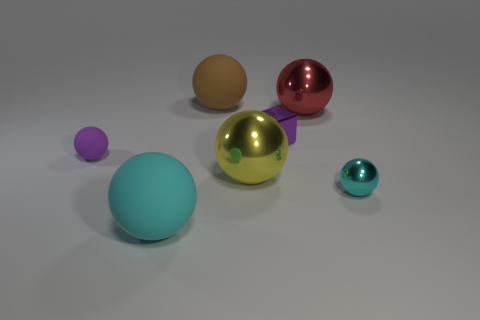Subtract 2 balls. How many balls are left? 4 Subtract all brown balls. How many balls are left? 5 Subtract all cyan balls. How many balls are left? 4 Subtract all purple balls. Subtract all yellow cylinders. How many balls are left? 5 Add 1 large metal things. How many objects exist? 8 Subtract all balls. How many objects are left? 1 Subtract 0 cyan cylinders. How many objects are left? 7 Subtract all large red metal things. Subtract all matte objects. How many objects are left? 3 Add 4 brown matte spheres. How many brown matte spheres are left? 5 Add 1 tiny rubber cubes. How many tiny rubber cubes exist? 1 